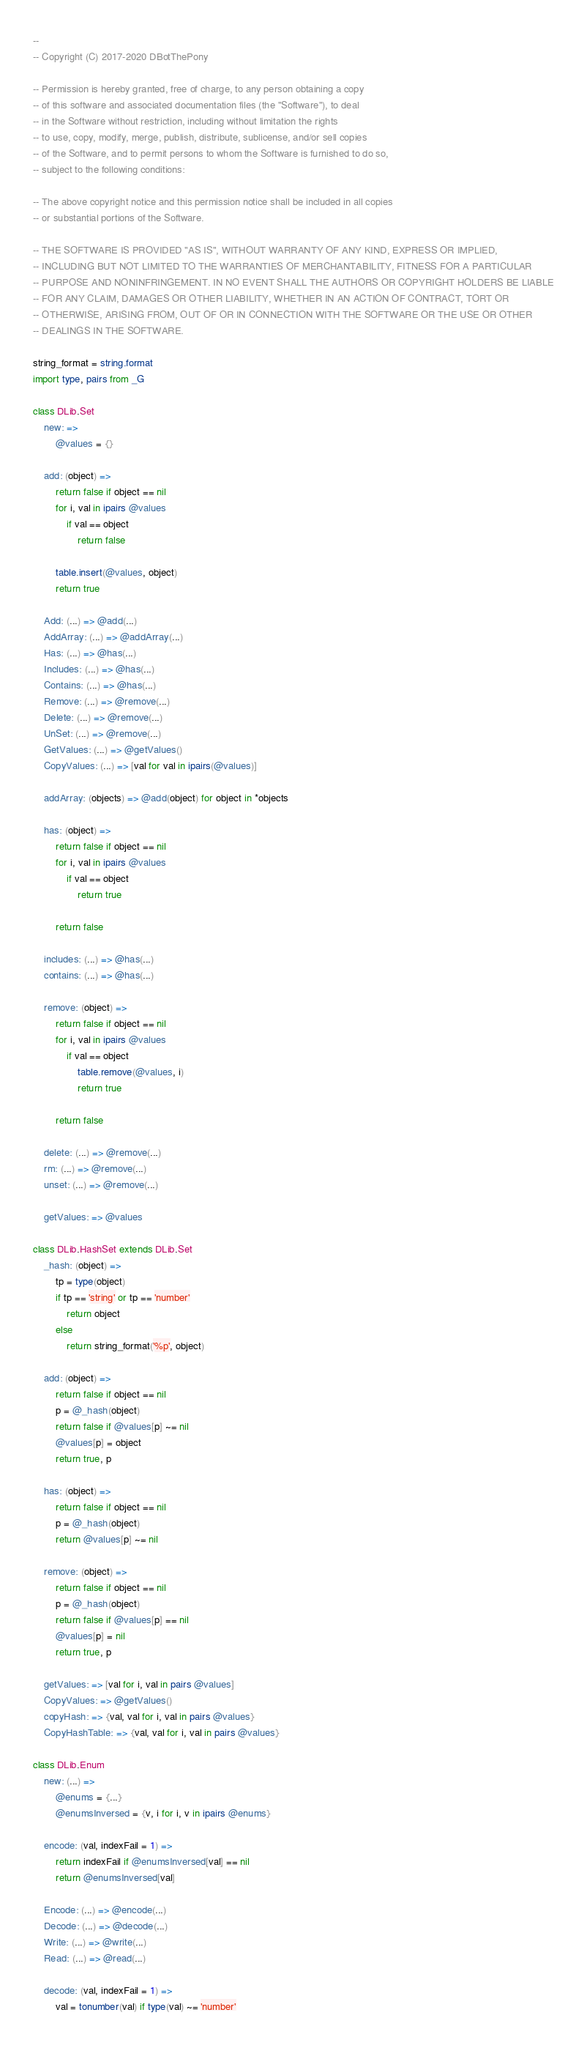Convert code to text. <code><loc_0><loc_0><loc_500><loc_500><_MoonScript_>
--
-- Copyright (C) 2017-2020 DBotThePony

-- Permission is hereby granted, free of charge, to any person obtaining a copy
-- of this software and associated documentation files (the "Software"), to deal
-- in the Software without restriction, including without limitation the rights
-- to use, copy, modify, merge, publish, distribute, sublicense, and/or sell copies
-- of the Software, and to permit persons to whom the Software is furnished to do so,
-- subject to the following conditions:

-- The above copyright notice and this permission notice shall be included in all copies
-- or substantial portions of the Software.

-- THE SOFTWARE IS PROVIDED "AS IS", WITHOUT WARRANTY OF ANY KIND, EXPRESS OR IMPLIED,
-- INCLUDING BUT NOT LIMITED TO THE WARRANTIES OF MERCHANTABILITY, FITNESS FOR A PARTICULAR
-- PURPOSE AND NONINFRINGEMENT. IN NO EVENT SHALL THE AUTHORS OR COPYRIGHT HOLDERS BE LIABLE
-- FOR ANY CLAIM, DAMAGES OR OTHER LIABILITY, WHETHER IN AN ACTION OF CONTRACT, TORT OR
-- OTHERWISE, ARISING FROM, OUT OF OR IN CONNECTION WITH THE SOFTWARE OR THE USE OR OTHER
-- DEALINGS IN THE SOFTWARE.

string_format = string.format
import type, pairs from _G

class DLib.Set
	new: =>
		@values = {}

	add: (object) =>
		return false if object == nil
		for i, val in ipairs @values
			if val == object
				return false

		table.insert(@values, object)
		return true

	Add: (...) => @add(...)
	AddArray: (...) => @addArray(...)
	Has: (...) => @has(...)
	Includes: (...) => @has(...)
	Contains: (...) => @has(...)
	Remove: (...) => @remove(...)
	Delete: (...) => @remove(...)
	UnSet: (...) => @remove(...)
	GetValues: (...) => @getValues()
	CopyValues: (...) => [val for val in ipairs(@values)]

	addArray: (objects) => @add(object) for object in *objects

	has: (object) =>
		return false if object == nil
		for i, val in ipairs @values
			if val == object
				return true

		return false

	includes: (...) => @has(...)
	contains: (...) => @has(...)

	remove: (object) =>
		return false if object == nil
		for i, val in ipairs @values
			if val == object
				table.remove(@values, i)
				return true

		return false

	delete: (...) => @remove(...)
	rm: (...) => @remove(...)
	unset: (...) => @remove(...)

	getValues: => @values

class DLib.HashSet extends DLib.Set
	_hash: (object) =>
		tp = type(object)
		if tp == 'string' or tp == 'number'
			return object
		else
			return string_format('%p', object)

	add: (object) =>
		return false if object == nil
		p = @_hash(object)
		return false if @values[p] ~= nil
		@values[p] = object
		return true, p

	has: (object) =>
		return false if object == nil
		p = @_hash(object)
		return @values[p] ~= nil

	remove: (object) =>
		return false if object == nil
		p = @_hash(object)
		return false if @values[p] == nil
		@values[p] = nil
		return true, p

	getValues: => [val for i, val in pairs @values]
	CopyValues: => @getValues()
	copyHash: => {val, val for i, val in pairs @values}
	CopyHashTable: => {val, val for i, val in pairs @values}

class DLib.Enum
	new: (...) =>
		@enums = {...}
		@enumsInversed = {v, i for i, v in ipairs @enums}

	encode: (val, indexFail = 1) =>
		return indexFail if @enumsInversed[val] == nil
		return @enumsInversed[val]

	Encode: (...) => @encode(...)
	Decode: (...) => @decode(...)
	Write: (...) => @write(...)
	Read: (...) => @read(...)

	decode: (val, indexFail = 1) =>
		val = tonumber(val) if type(val) ~= 'number'</code> 